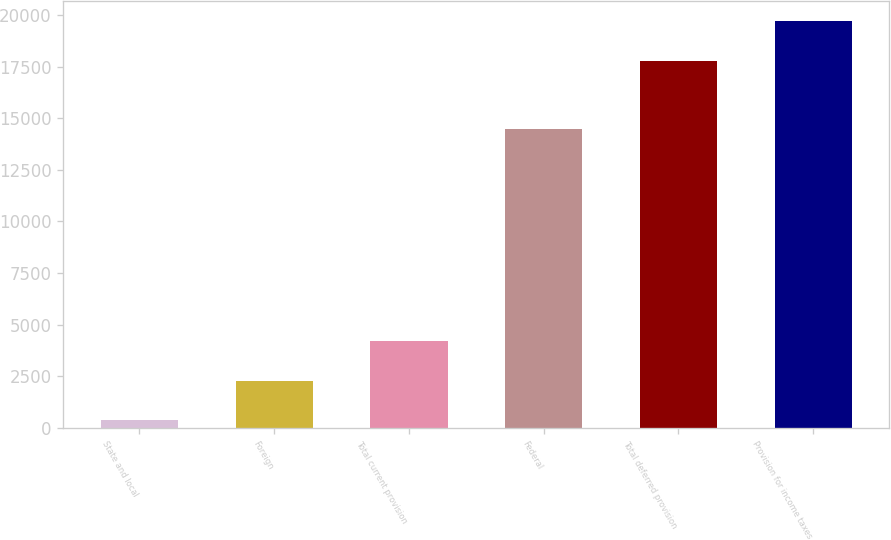Convert chart to OTSL. <chart><loc_0><loc_0><loc_500><loc_500><bar_chart><fcel>State and local<fcel>Foreign<fcel>Total current provision<fcel>Federal<fcel>Total deferred provision<fcel>Provision for income taxes<nl><fcel>355<fcel>2267.7<fcel>4180.4<fcel>14494<fcel>17779<fcel>19691.7<nl></chart> 